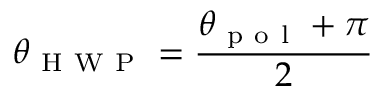Convert formula to latex. <formula><loc_0><loc_0><loc_500><loc_500>\theta _ { H W P } = \frac { \theta _ { p o l } + \pi } { 2 }</formula> 